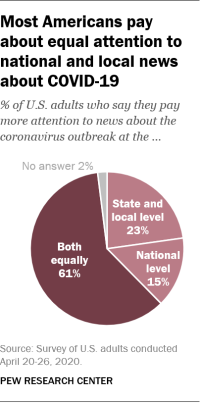Outline some significant characteristics in this image. The color of No answer is gray. It is not the case that the sum total of state and local level and national level efforts is more than both equally. In fact, no. 